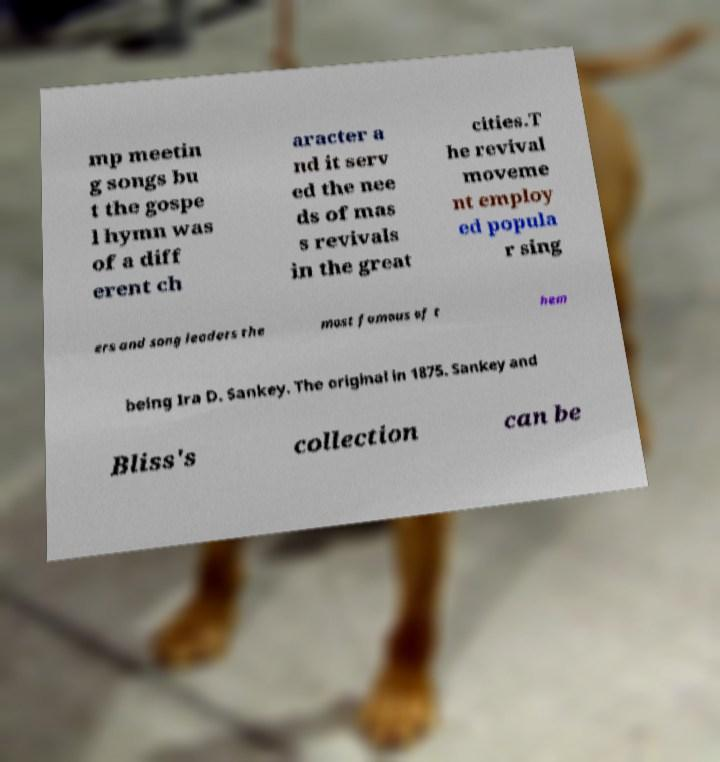For documentation purposes, I need the text within this image transcribed. Could you provide that? mp meetin g songs bu t the gospe l hymn was of a diff erent ch aracter a nd it serv ed the nee ds of mas s revivals in the great cities.T he revival moveme nt employ ed popula r sing ers and song leaders the most famous of t hem being Ira D. Sankey. The original in 1875. Sankey and Bliss's collection can be 